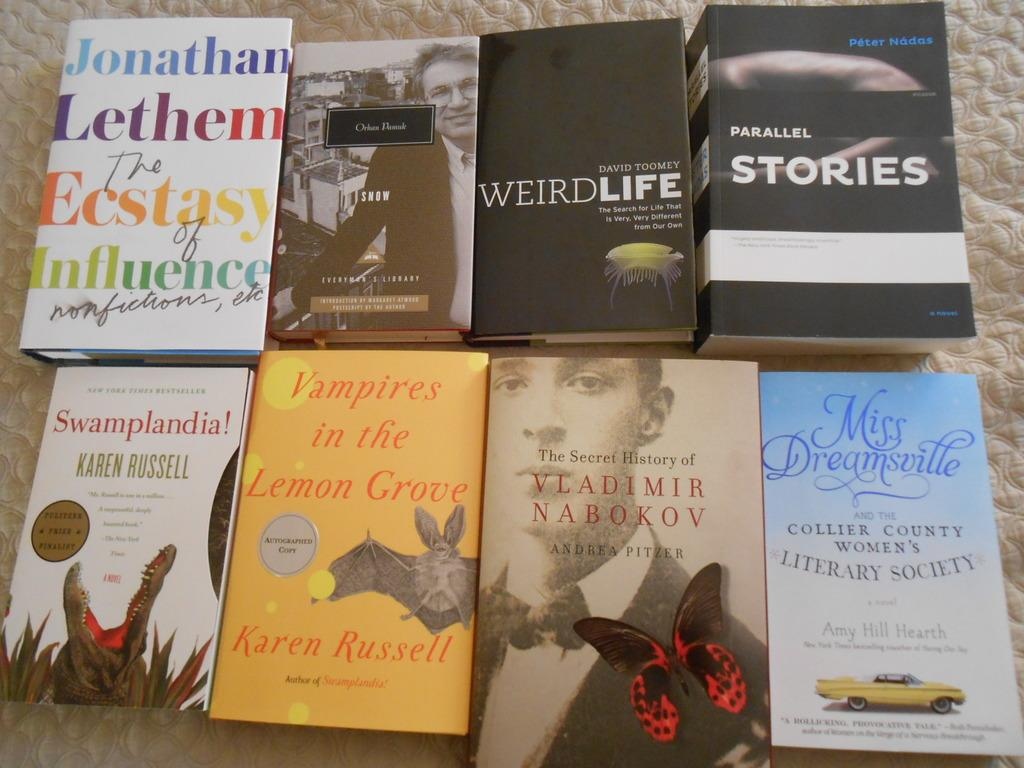<image>
Give a short and clear explanation of the subsequent image. a collection of books including Parallel Stories by Péter Nádas 